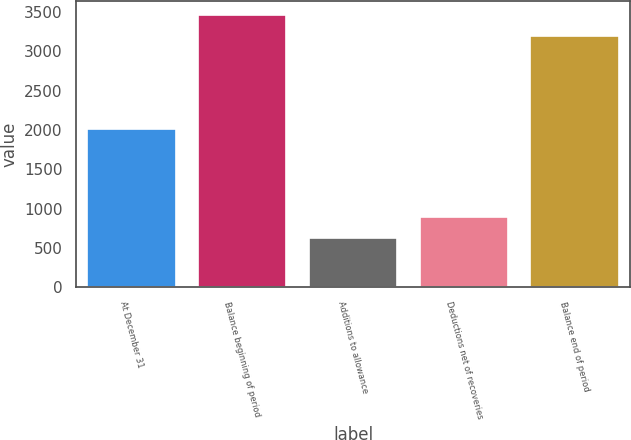<chart> <loc_0><loc_0><loc_500><loc_500><bar_chart><fcel>At December 31<fcel>Balance beginning of period<fcel>Additions to allowance<fcel>Deductions net of recoveries<fcel>Balance end of period<nl><fcel>2013<fcel>3462.4<fcel>626<fcel>888.4<fcel>3200<nl></chart> 